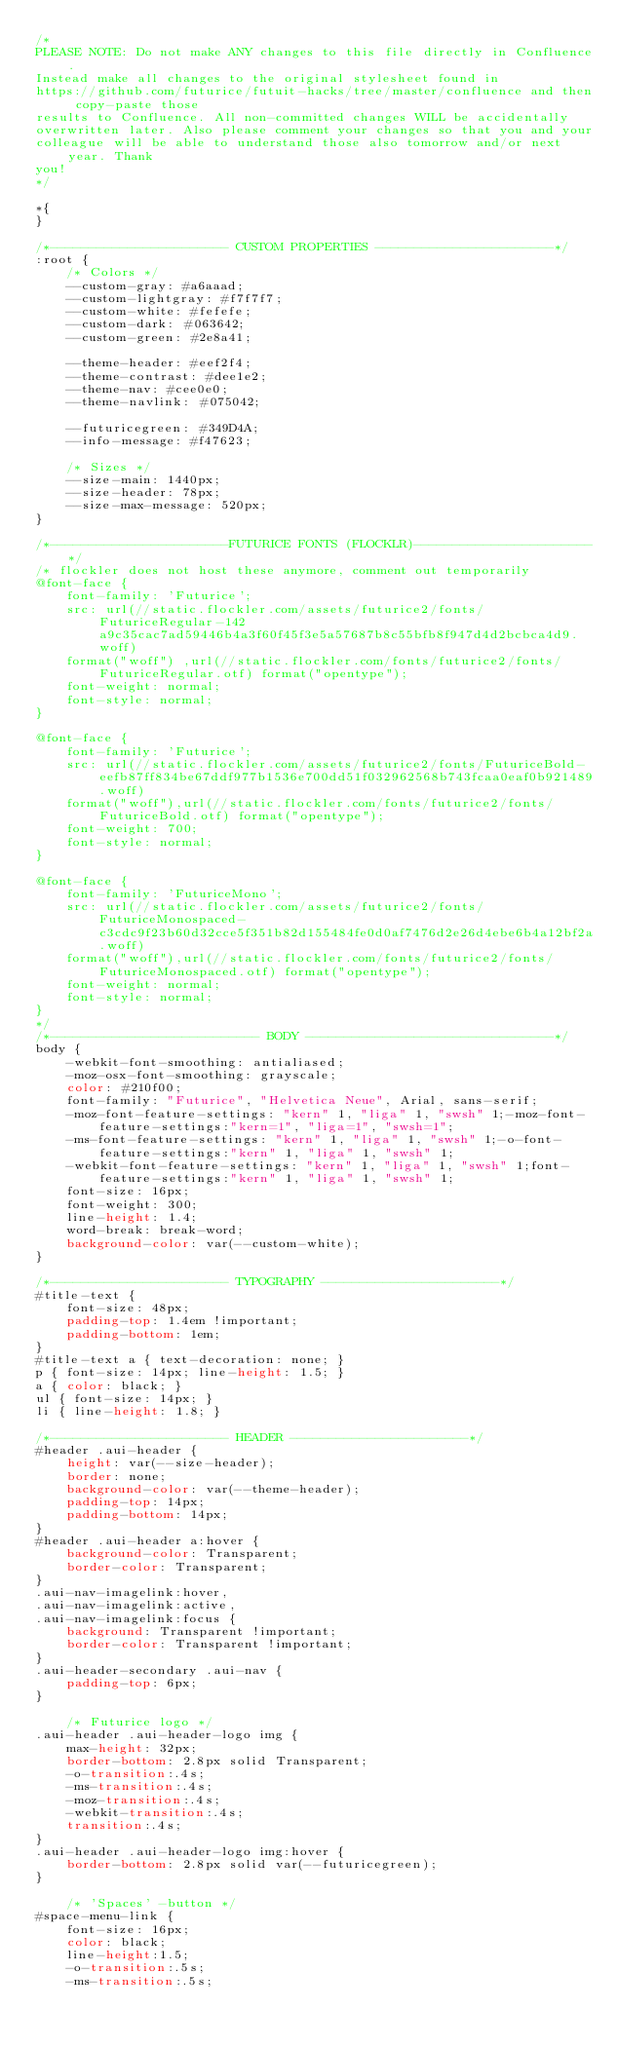<code> <loc_0><loc_0><loc_500><loc_500><_CSS_>/*
PLEASE NOTE: Do not make ANY changes to this file directly in Confluence.
Instead make all changes to the original stylesheet found in
https://github.com/futurice/futuit-hacks/tree/master/confluence and then copy-paste those
results to Confluence. All non-committed changes WILL be accidentally
overwritten later. Also please comment your changes so that you and your
colleague will be able to understand those also tomorrow and/or next year. Thank
you!
*/

*{
}

/*----------------------- CUSTOM PROPERTIES -----------------------*/
:root { 
    /* Colors */
    --custom-gray: #a6aaad;
    --custom-lightgray: #f7f7f7;
    --custom-white: #fefefe;
    --custom-dark: #063642;
    --custom-green: #2e8a41;

    --theme-header: #eef2f4;
    --theme-contrast: #dee1e2;
    --theme-nav: #cee0e0;
    --theme-navlink: #075042;

    --futuricegreen: #349D4A;
    --info-message: #f47623;

    /* Sizes */
    --size-main: 1440px;
    --size-header: 78px;
    --size-max-message: 520px;
}

/*-----------------------FUTURICE FONTS (FLOCKLR)-----------------------*/
/* flockler does not host these anymore, comment out temporarily
@font-face {  
    font-family: 'Futurice';  
    src: url(//static.flockler.com/assets/futurice2/fonts/FuturiceRegular-142a9c35cac7ad59446b4a3f60f45f3e5a57687b8c55bfb8f947d4d2bcbca4d9.woff) 
    format("woff") ,url(//static.flockler.com/fonts/futurice2/fonts/FuturiceRegular.otf) format("opentype");  
    font-weight: normal;  
    font-style: normal; 
}  
  
@font-face {  
    font-family: 'Futurice';  
    src: url(//static.flockler.com/assets/futurice2/fonts/FuturiceBold-eefb87ff834be67ddf977b1536e700dd51f032962568b743fcaa0eaf0b921489.woff) 
    format("woff"),url(//static.flockler.com/fonts/futurice2/fonts/FuturiceBold.otf) format("opentype");  
    font-weight: 700;  
    font-style: normal;
}  
  
@font-face {  
    font-family: 'FuturiceMono';  
    src: url(//static.flockler.com/assets/futurice2/fonts/FuturiceMonospaced-c3cdc9f23b60d32cce5f351b82d155484fe0d0af7476d2e26d4ebe6b4a12bf2a.woff) 
    format("woff"),url(//static.flockler.com/fonts/futurice2/fonts/FuturiceMonospaced.otf) format("opentype");  
    font-weight: normal;  
    font-style: normal;  
}
*/
/*--------------------------- BODY --------------------------------*/
body {  
    -webkit-font-smoothing: antialiased;  
    -moz-osx-font-smoothing: grayscale;  
    color: #210f00;  
    font-family: "Futurice", "Helvetica Neue", Arial, sans-serif;  
    -moz-font-feature-settings: "kern" 1, "liga" 1, "swsh" 1;-moz-font-feature-settings:"kern=1", "liga=1", "swsh=1";  
    -ms-font-feature-settings: "kern" 1, "liga" 1, "swsh" 1;-o-font-feature-settings:"kern" 1, "liga" 1, "swsh" 1;  
    -webkit-font-feature-settings: "kern" 1, "liga" 1, "swsh" 1;font-feature-settings:"kern" 1, "liga" 1, "swsh" 1;  
    font-size: 16px;  
    font-weight: 300;  
    line-height: 1.4;  
    word-break: break-word;
    background-color: var(--custom-white);
} 

/*----------------------- TYPOGRAPHY -----------------------*/ 
#title-text { 
    font-size: 48px; 
    padding-top: 1.4em !important; 
    padding-bottom: 1em;
}  
#title-text a { text-decoration: none; }  
p { font-size: 14px; line-height: 1.5; } 
a { color: black; }
ul { font-size: 14px; }  
li { line-height: 1.8; } 

/*----------------------- HEADER -----------------------*/
#header .aui-header { 
    height: var(--size-header);
    border: none; 
    background-color: var(--theme-header); 
    padding-top: 14px; 
    padding-bottom: 14px; 
}  
#header .aui-header a:hover {
    background-color: Transparent;
    border-color: Transparent;
}
.aui-nav-imagelink:hover,
.aui-nav-imagelink:active,
.aui-nav-imagelink:focus { 
    background: Transparent !important; 
    border-color: Transparent !important; 
}
.aui-header-secondary .aui-nav { 
    padding-top: 6px;
}

    /* Futurice logo */
.aui-header .aui-header-logo img { 
    max-height: 32px; 
    border-bottom: 2.8px solid Transparent; 
    -o-transition:.4s;
    -ms-transition:.4s;
    -moz-transition:.4s;
    -webkit-transition:.4s;
    transition:.4s;
}
.aui-header .aui-header-logo img:hover { 
    border-bottom: 2.8px solid var(--futuricegreen); 
}

    /* 'Spaces' -button */
#space-menu-link {
    font-size: 16px;
    color: black;
    line-height:1.5;
    -o-transition:.5s;
    -ms-transition:.5s;</code> 